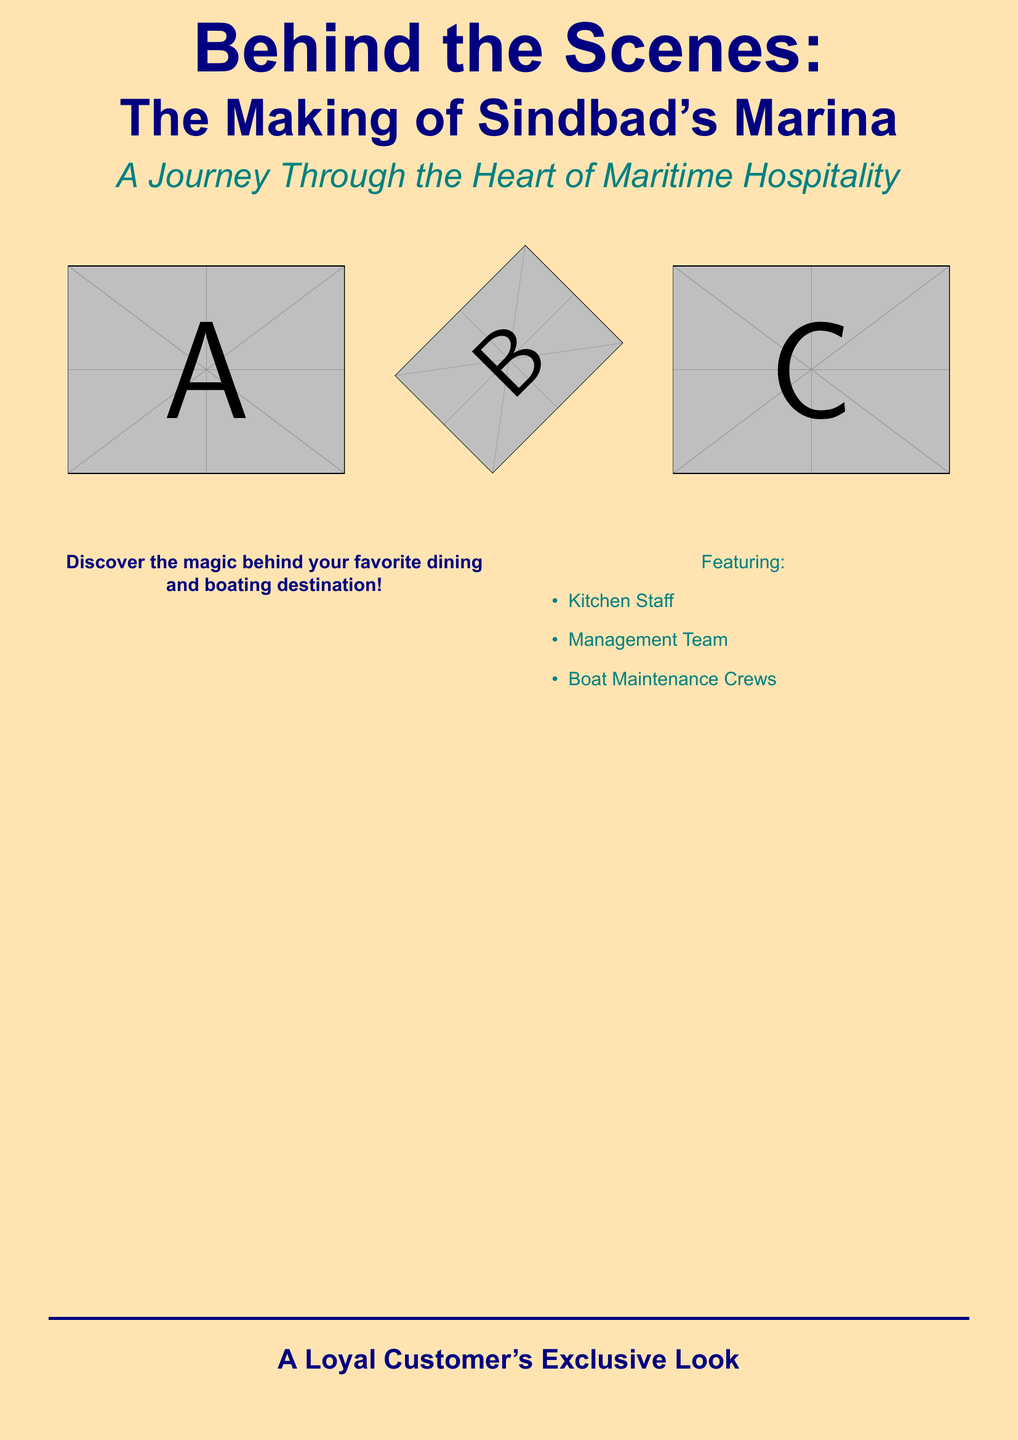What is the title of the book? The title is prominently displayed at the center of the cover, emphasizing the focus of the document.
Answer: Behind the Scenes: The Making of Sindbad's Marina What is the subtitle of the book? The subtitle provides additional context about the book's content and is located below the main title.
Answer: A Journey Through the Heart of Maritime Hospitality What colors dominate the book cover? The cover uses shades of orange, blue, and teal to create a nautical theme, especially the background and title text.
Answer: Sunset orange, navy blue, water teal How many main topics are featured in the document? The document includes a list of specific groups that contribute to the establishment, which is outlined in bullet points.
Answer: Three What is one of the featured groups mentioned in the cover? The document lists specific personnel involved in the operations, which helps to highlight the focus of the documentation.
Answer: Kitchen Staff What visual elements are included on the cover? The cover's design includes images that contribute to its aesthetic, specifically regarding the maritime theme.
Answer: Images of staff What type of elements integrate the design theme? The design incorporates specific motifs that reflect the theme of the establishment, enhancing the visual appeal.
Answer: Nautical elements What is stated regarding the perspective offered in the book? The wording on the cover suggests a unique viewpoint that enhances the reader's understanding of the establishment's operations.
Answer: A Loyal Customer's Exclusive Look How is the overall tone of the cover described? The combination of colors and imagery communicates a specific atmosphere that corresponds to the nature of the contents.
Answer: Serene and inviting 